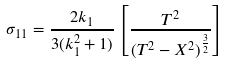Convert formula to latex. <formula><loc_0><loc_0><loc_500><loc_500>\sigma _ { 1 1 } = \frac { 2 k _ { 1 } } { 3 ( k ^ { 2 } _ { 1 } + 1 ) } \left [ \frac { T ^ { 2 } } { ( T ^ { 2 } - X ^ { 2 } ) ^ { \frac { 3 } { 2 } } } \right ]</formula> 